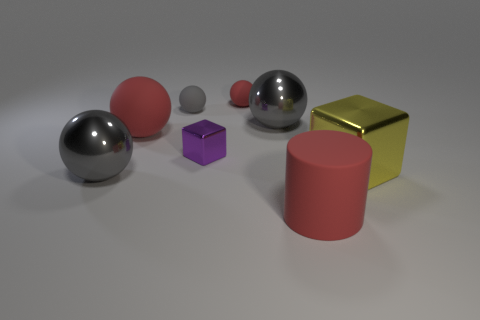There is a big metallic cube; is it the same color as the big rubber object left of the small red matte object?
Offer a very short reply. No. Are there more big matte objects on the right side of the small gray ball than objects?
Provide a short and direct response. No. How many things are tiny objects behind the purple thing or big gray balls in front of the small cube?
Offer a terse response. 3. There is a yellow block that is made of the same material as the small purple cube; what size is it?
Offer a terse response. Large. Do the red thing that is in front of the big rubber sphere and the large yellow thing have the same shape?
Provide a succinct answer. No. The other sphere that is the same color as the big rubber ball is what size?
Offer a very short reply. Small. How many yellow objects are either large things or spheres?
Make the answer very short. 1. What number of other things are the same shape as the small red object?
Offer a terse response. 4. What shape is the object that is in front of the large matte ball and behind the big yellow object?
Your answer should be very brief. Cube. There is a small purple metallic object; are there any large rubber things behind it?
Give a very brief answer. Yes. 